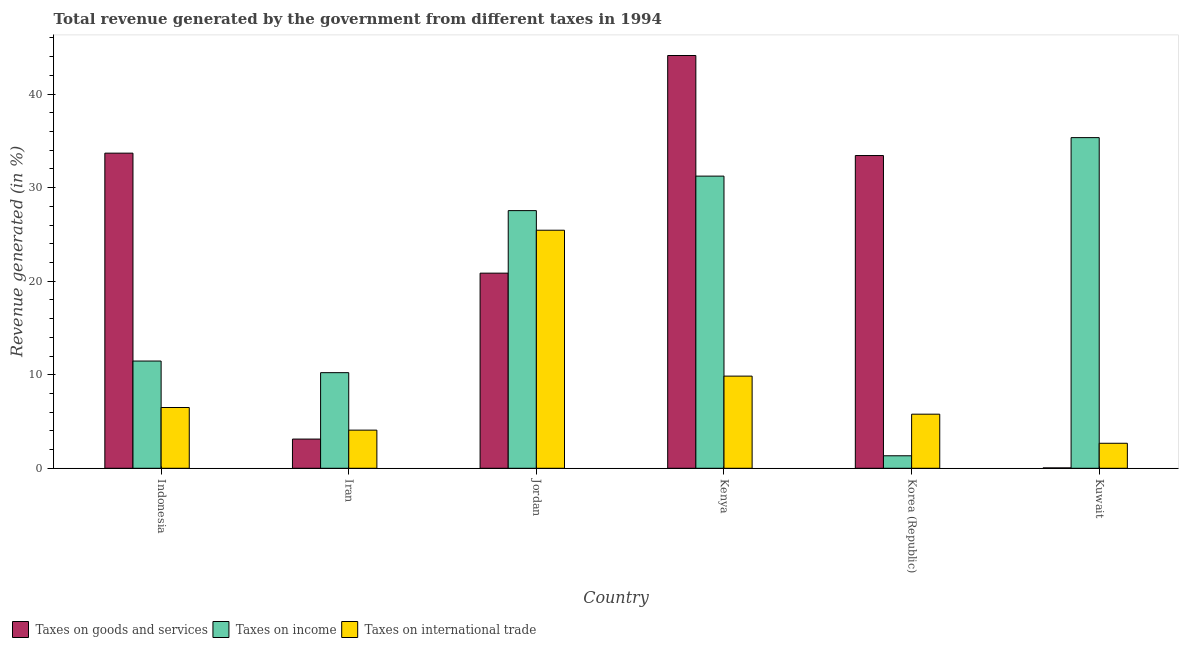How many groups of bars are there?
Your answer should be very brief. 6. Are the number of bars per tick equal to the number of legend labels?
Keep it short and to the point. Yes. How many bars are there on the 6th tick from the left?
Keep it short and to the point. 3. What is the label of the 3rd group of bars from the left?
Provide a succinct answer. Jordan. In how many cases, is the number of bars for a given country not equal to the number of legend labels?
Provide a succinct answer. 0. What is the percentage of revenue generated by taxes on income in Indonesia?
Ensure brevity in your answer.  11.46. Across all countries, what is the maximum percentage of revenue generated by taxes on goods and services?
Make the answer very short. 44.12. Across all countries, what is the minimum percentage of revenue generated by taxes on goods and services?
Provide a succinct answer. 0.04. In which country was the percentage of revenue generated by taxes on income maximum?
Provide a short and direct response. Kuwait. In which country was the percentage of revenue generated by taxes on goods and services minimum?
Offer a very short reply. Kuwait. What is the total percentage of revenue generated by tax on international trade in the graph?
Offer a terse response. 54.32. What is the difference between the percentage of revenue generated by taxes on goods and services in Indonesia and that in Korea (Republic)?
Make the answer very short. 0.26. What is the difference between the percentage of revenue generated by taxes on goods and services in Kenya and the percentage of revenue generated by tax on international trade in Indonesia?
Make the answer very short. 37.63. What is the average percentage of revenue generated by taxes on goods and services per country?
Ensure brevity in your answer.  22.54. What is the difference between the percentage of revenue generated by taxes on income and percentage of revenue generated by tax on international trade in Kenya?
Your answer should be very brief. 21.38. In how many countries, is the percentage of revenue generated by taxes on income greater than 28 %?
Offer a very short reply. 2. What is the ratio of the percentage of revenue generated by taxes on goods and services in Jordan to that in Korea (Republic)?
Ensure brevity in your answer.  0.62. Is the difference between the percentage of revenue generated by taxes on income in Iran and Kenya greater than the difference between the percentage of revenue generated by tax on international trade in Iran and Kenya?
Keep it short and to the point. No. What is the difference between the highest and the second highest percentage of revenue generated by taxes on income?
Your response must be concise. 4.11. What is the difference between the highest and the lowest percentage of revenue generated by tax on international trade?
Your response must be concise. 22.77. In how many countries, is the percentage of revenue generated by taxes on income greater than the average percentage of revenue generated by taxes on income taken over all countries?
Provide a short and direct response. 3. Is the sum of the percentage of revenue generated by tax on international trade in Jordan and Korea (Republic) greater than the maximum percentage of revenue generated by taxes on income across all countries?
Provide a short and direct response. No. What does the 1st bar from the left in Kuwait represents?
Provide a succinct answer. Taxes on goods and services. What does the 3rd bar from the right in Jordan represents?
Give a very brief answer. Taxes on goods and services. How many bars are there?
Provide a short and direct response. 18. Are all the bars in the graph horizontal?
Offer a terse response. No. How many countries are there in the graph?
Your answer should be compact. 6. Does the graph contain any zero values?
Your answer should be compact. No. Does the graph contain grids?
Provide a succinct answer. No. Where does the legend appear in the graph?
Ensure brevity in your answer.  Bottom left. How many legend labels are there?
Provide a short and direct response. 3. How are the legend labels stacked?
Give a very brief answer. Horizontal. What is the title of the graph?
Ensure brevity in your answer.  Total revenue generated by the government from different taxes in 1994. What is the label or title of the X-axis?
Your answer should be compact. Country. What is the label or title of the Y-axis?
Your response must be concise. Revenue generated (in %). What is the Revenue generated (in %) of Taxes on goods and services in Indonesia?
Your response must be concise. 33.68. What is the Revenue generated (in %) of Taxes on income in Indonesia?
Offer a very short reply. 11.46. What is the Revenue generated (in %) in Taxes on international trade in Indonesia?
Keep it short and to the point. 6.5. What is the Revenue generated (in %) of Taxes on goods and services in Iran?
Provide a succinct answer. 3.12. What is the Revenue generated (in %) in Taxes on income in Iran?
Offer a very short reply. 10.22. What is the Revenue generated (in %) of Taxes on international trade in Iran?
Give a very brief answer. 4.08. What is the Revenue generated (in %) of Taxes on goods and services in Jordan?
Your answer should be very brief. 20.86. What is the Revenue generated (in %) of Taxes on income in Jordan?
Your answer should be very brief. 27.54. What is the Revenue generated (in %) of Taxes on international trade in Jordan?
Your answer should be very brief. 25.45. What is the Revenue generated (in %) of Taxes on goods and services in Kenya?
Your answer should be compact. 44.12. What is the Revenue generated (in %) in Taxes on income in Kenya?
Your answer should be compact. 31.23. What is the Revenue generated (in %) in Taxes on international trade in Kenya?
Provide a succinct answer. 9.85. What is the Revenue generated (in %) in Taxes on goods and services in Korea (Republic)?
Provide a short and direct response. 33.43. What is the Revenue generated (in %) of Taxes on income in Korea (Republic)?
Your answer should be very brief. 1.34. What is the Revenue generated (in %) of Taxes on international trade in Korea (Republic)?
Provide a short and direct response. 5.78. What is the Revenue generated (in %) in Taxes on goods and services in Kuwait?
Your response must be concise. 0.04. What is the Revenue generated (in %) in Taxes on income in Kuwait?
Your answer should be compact. 35.34. What is the Revenue generated (in %) of Taxes on international trade in Kuwait?
Ensure brevity in your answer.  2.67. Across all countries, what is the maximum Revenue generated (in %) in Taxes on goods and services?
Your response must be concise. 44.12. Across all countries, what is the maximum Revenue generated (in %) of Taxes on income?
Make the answer very short. 35.34. Across all countries, what is the maximum Revenue generated (in %) of Taxes on international trade?
Ensure brevity in your answer.  25.45. Across all countries, what is the minimum Revenue generated (in %) in Taxes on goods and services?
Provide a succinct answer. 0.04. Across all countries, what is the minimum Revenue generated (in %) in Taxes on income?
Give a very brief answer. 1.34. Across all countries, what is the minimum Revenue generated (in %) in Taxes on international trade?
Offer a terse response. 2.67. What is the total Revenue generated (in %) in Taxes on goods and services in the graph?
Give a very brief answer. 135.25. What is the total Revenue generated (in %) of Taxes on income in the graph?
Offer a terse response. 117.13. What is the total Revenue generated (in %) in Taxes on international trade in the graph?
Give a very brief answer. 54.32. What is the difference between the Revenue generated (in %) in Taxes on goods and services in Indonesia and that in Iran?
Offer a very short reply. 30.56. What is the difference between the Revenue generated (in %) of Taxes on income in Indonesia and that in Iran?
Provide a short and direct response. 1.24. What is the difference between the Revenue generated (in %) of Taxes on international trade in Indonesia and that in Iran?
Your answer should be very brief. 2.42. What is the difference between the Revenue generated (in %) of Taxes on goods and services in Indonesia and that in Jordan?
Offer a very short reply. 12.83. What is the difference between the Revenue generated (in %) in Taxes on income in Indonesia and that in Jordan?
Your answer should be compact. -16.08. What is the difference between the Revenue generated (in %) of Taxes on international trade in Indonesia and that in Jordan?
Give a very brief answer. -18.95. What is the difference between the Revenue generated (in %) in Taxes on goods and services in Indonesia and that in Kenya?
Your answer should be very brief. -10.44. What is the difference between the Revenue generated (in %) in Taxes on income in Indonesia and that in Kenya?
Your response must be concise. -19.77. What is the difference between the Revenue generated (in %) of Taxes on international trade in Indonesia and that in Kenya?
Your answer should be compact. -3.36. What is the difference between the Revenue generated (in %) of Taxes on goods and services in Indonesia and that in Korea (Republic)?
Provide a short and direct response. 0.26. What is the difference between the Revenue generated (in %) of Taxes on income in Indonesia and that in Korea (Republic)?
Your answer should be very brief. 10.13. What is the difference between the Revenue generated (in %) in Taxes on international trade in Indonesia and that in Korea (Republic)?
Provide a short and direct response. 0.71. What is the difference between the Revenue generated (in %) of Taxes on goods and services in Indonesia and that in Kuwait?
Provide a short and direct response. 33.65. What is the difference between the Revenue generated (in %) of Taxes on income in Indonesia and that in Kuwait?
Make the answer very short. -23.88. What is the difference between the Revenue generated (in %) of Taxes on international trade in Indonesia and that in Kuwait?
Offer a terse response. 3.82. What is the difference between the Revenue generated (in %) of Taxes on goods and services in Iran and that in Jordan?
Offer a terse response. -17.74. What is the difference between the Revenue generated (in %) in Taxes on income in Iran and that in Jordan?
Give a very brief answer. -17.32. What is the difference between the Revenue generated (in %) of Taxes on international trade in Iran and that in Jordan?
Provide a short and direct response. -21.37. What is the difference between the Revenue generated (in %) in Taxes on goods and services in Iran and that in Kenya?
Provide a short and direct response. -41. What is the difference between the Revenue generated (in %) in Taxes on income in Iran and that in Kenya?
Make the answer very short. -21.01. What is the difference between the Revenue generated (in %) of Taxes on international trade in Iran and that in Kenya?
Your answer should be very brief. -5.77. What is the difference between the Revenue generated (in %) of Taxes on goods and services in Iran and that in Korea (Republic)?
Ensure brevity in your answer.  -30.31. What is the difference between the Revenue generated (in %) in Taxes on income in Iran and that in Korea (Republic)?
Give a very brief answer. 8.88. What is the difference between the Revenue generated (in %) of Taxes on international trade in Iran and that in Korea (Republic)?
Provide a short and direct response. -1.7. What is the difference between the Revenue generated (in %) of Taxes on goods and services in Iran and that in Kuwait?
Keep it short and to the point. 3.08. What is the difference between the Revenue generated (in %) in Taxes on income in Iran and that in Kuwait?
Offer a very short reply. -25.12. What is the difference between the Revenue generated (in %) of Taxes on international trade in Iran and that in Kuwait?
Provide a succinct answer. 1.41. What is the difference between the Revenue generated (in %) of Taxes on goods and services in Jordan and that in Kenya?
Your answer should be very brief. -23.26. What is the difference between the Revenue generated (in %) of Taxes on income in Jordan and that in Kenya?
Provide a short and direct response. -3.69. What is the difference between the Revenue generated (in %) of Taxes on international trade in Jordan and that in Kenya?
Offer a very short reply. 15.59. What is the difference between the Revenue generated (in %) of Taxes on goods and services in Jordan and that in Korea (Republic)?
Offer a terse response. -12.57. What is the difference between the Revenue generated (in %) of Taxes on income in Jordan and that in Korea (Republic)?
Offer a very short reply. 26.21. What is the difference between the Revenue generated (in %) of Taxes on international trade in Jordan and that in Korea (Republic)?
Your answer should be compact. 19.66. What is the difference between the Revenue generated (in %) in Taxes on goods and services in Jordan and that in Kuwait?
Your answer should be very brief. 20.82. What is the difference between the Revenue generated (in %) of Taxes on income in Jordan and that in Kuwait?
Give a very brief answer. -7.8. What is the difference between the Revenue generated (in %) of Taxes on international trade in Jordan and that in Kuwait?
Provide a succinct answer. 22.77. What is the difference between the Revenue generated (in %) of Taxes on goods and services in Kenya and that in Korea (Republic)?
Offer a terse response. 10.69. What is the difference between the Revenue generated (in %) in Taxes on income in Kenya and that in Korea (Republic)?
Provide a succinct answer. 29.89. What is the difference between the Revenue generated (in %) of Taxes on international trade in Kenya and that in Korea (Republic)?
Give a very brief answer. 4.07. What is the difference between the Revenue generated (in %) of Taxes on goods and services in Kenya and that in Kuwait?
Your answer should be compact. 44.08. What is the difference between the Revenue generated (in %) of Taxes on income in Kenya and that in Kuwait?
Offer a terse response. -4.11. What is the difference between the Revenue generated (in %) in Taxes on international trade in Kenya and that in Kuwait?
Your answer should be very brief. 7.18. What is the difference between the Revenue generated (in %) in Taxes on goods and services in Korea (Republic) and that in Kuwait?
Your answer should be very brief. 33.39. What is the difference between the Revenue generated (in %) of Taxes on income in Korea (Republic) and that in Kuwait?
Offer a very short reply. -34.01. What is the difference between the Revenue generated (in %) of Taxes on international trade in Korea (Republic) and that in Kuwait?
Your answer should be compact. 3.11. What is the difference between the Revenue generated (in %) in Taxes on goods and services in Indonesia and the Revenue generated (in %) in Taxes on income in Iran?
Keep it short and to the point. 23.47. What is the difference between the Revenue generated (in %) of Taxes on goods and services in Indonesia and the Revenue generated (in %) of Taxes on international trade in Iran?
Give a very brief answer. 29.61. What is the difference between the Revenue generated (in %) in Taxes on income in Indonesia and the Revenue generated (in %) in Taxes on international trade in Iran?
Your answer should be very brief. 7.39. What is the difference between the Revenue generated (in %) of Taxes on goods and services in Indonesia and the Revenue generated (in %) of Taxes on income in Jordan?
Offer a very short reply. 6.14. What is the difference between the Revenue generated (in %) of Taxes on goods and services in Indonesia and the Revenue generated (in %) of Taxes on international trade in Jordan?
Give a very brief answer. 8.24. What is the difference between the Revenue generated (in %) in Taxes on income in Indonesia and the Revenue generated (in %) in Taxes on international trade in Jordan?
Keep it short and to the point. -13.98. What is the difference between the Revenue generated (in %) in Taxes on goods and services in Indonesia and the Revenue generated (in %) in Taxes on income in Kenya?
Keep it short and to the point. 2.45. What is the difference between the Revenue generated (in %) in Taxes on goods and services in Indonesia and the Revenue generated (in %) in Taxes on international trade in Kenya?
Your answer should be very brief. 23.83. What is the difference between the Revenue generated (in %) in Taxes on income in Indonesia and the Revenue generated (in %) in Taxes on international trade in Kenya?
Your answer should be very brief. 1.61. What is the difference between the Revenue generated (in %) of Taxes on goods and services in Indonesia and the Revenue generated (in %) of Taxes on income in Korea (Republic)?
Keep it short and to the point. 32.35. What is the difference between the Revenue generated (in %) of Taxes on goods and services in Indonesia and the Revenue generated (in %) of Taxes on international trade in Korea (Republic)?
Make the answer very short. 27.9. What is the difference between the Revenue generated (in %) of Taxes on income in Indonesia and the Revenue generated (in %) of Taxes on international trade in Korea (Republic)?
Make the answer very short. 5.68. What is the difference between the Revenue generated (in %) in Taxes on goods and services in Indonesia and the Revenue generated (in %) in Taxes on income in Kuwait?
Your answer should be compact. -1.66. What is the difference between the Revenue generated (in %) in Taxes on goods and services in Indonesia and the Revenue generated (in %) in Taxes on international trade in Kuwait?
Keep it short and to the point. 31.01. What is the difference between the Revenue generated (in %) of Taxes on income in Indonesia and the Revenue generated (in %) of Taxes on international trade in Kuwait?
Provide a succinct answer. 8.79. What is the difference between the Revenue generated (in %) of Taxes on goods and services in Iran and the Revenue generated (in %) of Taxes on income in Jordan?
Offer a terse response. -24.42. What is the difference between the Revenue generated (in %) in Taxes on goods and services in Iran and the Revenue generated (in %) in Taxes on international trade in Jordan?
Ensure brevity in your answer.  -22.32. What is the difference between the Revenue generated (in %) in Taxes on income in Iran and the Revenue generated (in %) in Taxes on international trade in Jordan?
Provide a succinct answer. -15.23. What is the difference between the Revenue generated (in %) in Taxes on goods and services in Iran and the Revenue generated (in %) in Taxes on income in Kenya?
Offer a terse response. -28.11. What is the difference between the Revenue generated (in %) in Taxes on goods and services in Iran and the Revenue generated (in %) in Taxes on international trade in Kenya?
Make the answer very short. -6.73. What is the difference between the Revenue generated (in %) of Taxes on income in Iran and the Revenue generated (in %) of Taxes on international trade in Kenya?
Your response must be concise. 0.37. What is the difference between the Revenue generated (in %) in Taxes on goods and services in Iran and the Revenue generated (in %) in Taxes on income in Korea (Republic)?
Your answer should be compact. 1.78. What is the difference between the Revenue generated (in %) in Taxes on goods and services in Iran and the Revenue generated (in %) in Taxes on international trade in Korea (Republic)?
Your answer should be compact. -2.66. What is the difference between the Revenue generated (in %) in Taxes on income in Iran and the Revenue generated (in %) in Taxes on international trade in Korea (Republic)?
Keep it short and to the point. 4.44. What is the difference between the Revenue generated (in %) in Taxes on goods and services in Iran and the Revenue generated (in %) in Taxes on income in Kuwait?
Make the answer very short. -32.22. What is the difference between the Revenue generated (in %) of Taxes on goods and services in Iran and the Revenue generated (in %) of Taxes on international trade in Kuwait?
Keep it short and to the point. 0.45. What is the difference between the Revenue generated (in %) in Taxes on income in Iran and the Revenue generated (in %) in Taxes on international trade in Kuwait?
Your answer should be very brief. 7.55. What is the difference between the Revenue generated (in %) in Taxes on goods and services in Jordan and the Revenue generated (in %) in Taxes on income in Kenya?
Give a very brief answer. -10.37. What is the difference between the Revenue generated (in %) of Taxes on goods and services in Jordan and the Revenue generated (in %) of Taxes on international trade in Kenya?
Ensure brevity in your answer.  11.01. What is the difference between the Revenue generated (in %) of Taxes on income in Jordan and the Revenue generated (in %) of Taxes on international trade in Kenya?
Offer a terse response. 17.69. What is the difference between the Revenue generated (in %) of Taxes on goods and services in Jordan and the Revenue generated (in %) of Taxes on income in Korea (Republic)?
Your response must be concise. 19.52. What is the difference between the Revenue generated (in %) of Taxes on goods and services in Jordan and the Revenue generated (in %) of Taxes on international trade in Korea (Republic)?
Offer a very short reply. 15.08. What is the difference between the Revenue generated (in %) of Taxes on income in Jordan and the Revenue generated (in %) of Taxes on international trade in Korea (Republic)?
Give a very brief answer. 21.76. What is the difference between the Revenue generated (in %) in Taxes on goods and services in Jordan and the Revenue generated (in %) in Taxes on income in Kuwait?
Offer a terse response. -14.49. What is the difference between the Revenue generated (in %) in Taxes on goods and services in Jordan and the Revenue generated (in %) in Taxes on international trade in Kuwait?
Your response must be concise. 18.19. What is the difference between the Revenue generated (in %) in Taxes on income in Jordan and the Revenue generated (in %) in Taxes on international trade in Kuwait?
Keep it short and to the point. 24.87. What is the difference between the Revenue generated (in %) in Taxes on goods and services in Kenya and the Revenue generated (in %) in Taxes on income in Korea (Republic)?
Offer a terse response. 42.78. What is the difference between the Revenue generated (in %) of Taxes on goods and services in Kenya and the Revenue generated (in %) of Taxes on international trade in Korea (Republic)?
Provide a succinct answer. 38.34. What is the difference between the Revenue generated (in %) in Taxes on income in Kenya and the Revenue generated (in %) in Taxes on international trade in Korea (Republic)?
Offer a very short reply. 25.45. What is the difference between the Revenue generated (in %) in Taxes on goods and services in Kenya and the Revenue generated (in %) in Taxes on income in Kuwait?
Keep it short and to the point. 8.78. What is the difference between the Revenue generated (in %) in Taxes on goods and services in Kenya and the Revenue generated (in %) in Taxes on international trade in Kuwait?
Ensure brevity in your answer.  41.45. What is the difference between the Revenue generated (in %) in Taxes on income in Kenya and the Revenue generated (in %) in Taxes on international trade in Kuwait?
Your answer should be compact. 28.56. What is the difference between the Revenue generated (in %) of Taxes on goods and services in Korea (Republic) and the Revenue generated (in %) of Taxes on income in Kuwait?
Provide a succinct answer. -1.92. What is the difference between the Revenue generated (in %) in Taxes on goods and services in Korea (Republic) and the Revenue generated (in %) in Taxes on international trade in Kuwait?
Offer a very short reply. 30.76. What is the difference between the Revenue generated (in %) of Taxes on income in Korea (Republic) and the Revenue generated (in %) of Taxes on international trade in Kuwait?
Offer a very short reply. -1.34. What is the average Revenue generated (in %) of Taxes on goods and services per country?
Keep it short and to the point. 22.54. What is the average Revenue generated (in %) in Taxes on income per country?
Ensure brevity in your answer.  19.52. What is the average Revenue generated (in %) of Taxes on international trade per country?
Your answer should be compact. 9.05. What is the difference between the Revenue generated (in %) in Taxes on goods and services and Revenue generated (in %) in Taxes on income in Indonesia?
Your answer should be compact. 22.22. What is the difference between the Revenue generated (in %) of Taxes on goods and services and Revenue generated (in %) of Taxes on international trade in Indonesia?
Ensure brevity in your answer.  27.19. What is the difference between the Revenue generated (in %) of Taxes on income and Revenue generated (in %) of Taxes on international trade in Indonesia?
Your answer should be compact. 4.97. What is the difference between the Revenue generated (in %) of Taxes on goods and services and Revenue generated (in %) of Taxes on income in Iran?
Provide a succinct answer. -7.1. What is the difference between the Revenue generated (in %) in Taxes on goods and services and Revenue generated (in %) in Taxes on international trade in Iran?
Your answer should be compact. -0.96. What is the difference between the Revenue generated (in %) of Taxes on income and Revenue generated (in %) of Taxes on international trade in Iran?
Offer a terse response. 6.14. What is the difference between the Revenue generated (in %) of Taxes on goods and services and Revenue generated (in %) of Taxes on income in Jordan?
Offer a very short reply. -6.68. What is the difference between the Revenue generated (in %) of Taxes on goods and services and Revenue generated (in %) of Taxes on international trade in Jordan?
Your response must be concise. -4.59. What is the difference between the Revenue generated (in %) of Taxes on income and Revenue generated (in %) of Taxes on international trade in Jordan?
Your answer should be very brief. 2.1. What is the difference between the Revenue generated (in %) in Taxes on goods and services and Revenue generated (in %) in Taxes on income in Kenya?
Your answer should be compact. 12.89. What is the difference between the Revenue generated (in %) in Taxes on goods and services and Revenue generated (in %) in Taxes on international trade in Kenya?
Give a very brief answer. 34.27. What is the difference between the Revenue generated (in %) of Taxes on income and Revenue generated (in %) of Taxes on international trade in Kenya?
Your response must be concise. 21.38. What is the difference between the Revenue generated (in %) of Taxes on goods and services and Revenue generated (in %) of Taxes on income in Korea (Republic)?
Keep it short and to the point. 32.09. What is the difference between the Revenue generated (in %) of Taxes on goods and services and Revenue generated (in %) of Taxes on international trade in Korea (Republic)?
Make the answer very short. 27.65. What is the difference between the Revenue generated (in %) of Taxes on income and Revenue generated (in %) of Taxes on international trade in Korea (Republic)?
Provide a succinct answer. -4.45. What is the difference between the Revenue generated (in %) of Taxes on goods and services and Revenue generated (in %) of Taxes on income in Kuwait?
Keep it short and to the point. -35.3. What is the difference between the Revenue generated (in %) in Taxes on goods and services and Revenue generated (in %) in Taxes on international trade in Kuwait?
Keep it short and to the point. -2.63. What is the difference between the Revenue generated (in %) in Taxes on income and Revenue generated (in %) in Taxes on international trade in Kuwait?
Your response must be concise. 32.67. What is the ratio of the Revenue generated (in %) in Taxes on goods and services in Indonesia to that in Iran?
Your response must be concise. 10.79. What is the ratio of the Revenue generated (in %) of Taxes on income in Indonesia to that in Iran?
Provide a short and direct response. 1.12. What is the ratio of the Revenue generated (in %) of Taxes on international trade in Indonesia to that in Iran?
Your answer should be very brief. 1.59. What is the ratio of the Revenue generated (in %) in Taxes on goods and services in Indonesia to that in Jordan?
Keep it short and to the point. 1.61. What is the ratio of the Revenue generated (in %) of Taxes on income in Indonesia to that in Jordan?
Give a very brief answer. 0.42. What is the ratio of the Revenue generated (in %) in Taxes on international trade in Indonesia to that in Jordan?
Give a very brief answer. 0.26. What is the ratio of the Revenue generated (in %) in Taxes on goods and services in Indonesia to that in Kenya?
Offer a very short reply. 0.76. What is the ratio of the Revenue generated (in %) of Taxes on income in Indonesia to that in Kenya?
Offer a terse response. 0.37. What is the ratio of the Revenue generated (in %) of Taxes on international trade in Indonesia to that in Kenya?
Keep it short and to the point. 0.66. What is the ratio of the Revenue generated (in %) of Taxes on goods and services in Indonesia to that in Korea (Republic)?
Offer a terse response. 1.01. What is the ratio of the Revenue generated (in %) of Taxes on income in Indonesia to that in Korea (Republic)?
Keep it short and to the point. 8.58. What is the ratio of the Revenue generated (in %) of Taxes on international trade in Indonesia to that in Korea (Republic)?
Offer a terse response. 1.12. What is the ratio of the Revenue generated (in %) of Taxes on goods and services in Indonesia to that in Kuwait?
Make the answer very short. 857.27. What is the ratio of the Revenue generated (in %) in Taxes on income in Indonesia to that in Kuwait?
Your answer should be very brief. 0.32. What is the ratio of the Revenue generated (in %) in Taxes on international trade in Indonesia to that in Kuwait?
Ensure brevity in your answer.  2.43. What is the ratio of the Revenue generated (in %) in Taxes on goods and services in Iran to that in Jordan?
Provide a succinct answer. 0.15. What is the ratio of the Revenue generated (in %) of Taxes on income in Iran to that in Jordan?
Give a very brief answer. 0.37. What is the ratio of the Revenue generated (in %) in Taxes on international trade in Iran to that in Jordan?
Your response must be concise. 0.16. What is the ratio of the Revenue generated (in %) in Taxes on goods and services in Iran to that in Kenya?
Give a very brief answer. 0.07. What is the ratio of the Revenue generated (in %) of Taxes on income in Iran to that in Kenya?
Give a very brief answer. 0.33. What is the ratio of the Revenue generated (in %) in Taxes on international trade in Iran to that in Kenya?
Provide a succinct answer. 0.41. What is the ratio of the Revenue generated (in %) in Taxes on goods and services in Iran to that in Korea (Republic)?
Give a very brief answer. 0.09. What is the ratio of the Revenue generated (in %) of Taxes on income in Iran to that in Korea (Republic)?
Provide a short and direct response. 7.65. What is the ratio of the Revenue generated (in %) in Taxes on international trade in Iran to that in Korea (Republic)?
Offer a terse response. 0.71. What is the ratio of the Revenue generated (in %) of Taxes on goods and services in Iran to that in Kuwait?
Offer a very short reply. 79.43. What is the ratio of the Revenue generated (in %) of Taxes on income in Iran to that in Kuwait?
Your answer should be very brief. 0.29. What is the ratio of the Revenue generated (in %) in Taxes on international trade in Iran to that in Kuwait?
Your answer should be very brief. 1.53. What is the ratio of the Revenue generated (in %) of Taxes on goods and services in Jordan to that in Kenya?
Your answer should be compact. 0.47. What is the ratio of the Revenue generated (in %) in Taxes on income in Jordan to that in Kenya?
Make the answer very short. 0.88. What is the ratio of the Revenue generated (in %) of Taxes on international trade in Jordan to that in Kenya?
Make the answer very short. 2.58. What is the ratio of the Revenue generated (in %) in Taxes on goods and services in Jordan to that in Korea (Republic)?
Your answer should be very brief. 0.62. What is the ratio of the Revenue generated (in %) of Taxes on income in Jordan to that in Korea (Republic)?
Your answer should be very brief. 20.62. What is the ratio of the Revenue generated (in %) in Taxes on international trade in Jordan to that in Korea (Republic)?
Offer a very short reply. 4.4. What is the ratio of the Revenue generated (in %) in Taxes on goods and services in Jordan to that in Kuwait?
Give a very brief answer. 530.82. What is the ratio of the Revenue generated (in %) in Taxes on income in Jordan to that in Kuwait?
Your answer should be compact. 0.78. What is the ratio of the Revenue generated (in %) of Taxes on international trade in Jordan to that in Kuwait?
Your answer should be compact. 9.52. What is the ratio of the Revenue generated (in %) in Taxes on goods and services in Kenya to that in Korea (Republic)?
Give a very brief answer. 1.32. What is the ratio of the Revenue generated (in %) in Taxes on income in Kenya to that in Korea (Republic)?
Your answer should be very brief. 23.38. What is the ratio of the Revenue generated (in %) in Taxes on international trade in Kenya to that in Korea (Republic)?
Provide a succinct answer. 1.7. What is the ratio of the Revenue generated (in %) in Taxes on goods and services in Kenya to that in Kuwait?
Give a very brief answer. 1122.87. What is the ratio of the Revenue generated (in %) in Taxes on income in Kenya to that in Kuwait?
Provide a succinct answer. 0.88. What is the ratio of the Revenue generated (in %) in Taxes on international trade in Kenya to that in Kuwait?
Provide a succinct answer. 3.69. What is the ratio of the Revenue generated (in %) in Taxes on goods and services in Korea (Republic) to that in Kuwait?
Ensure brevity in your answer.  850.75. What is the ratio of the Revenue generated (in %) in Taxes on income in Korea (Republic) to that in Kuwait?
Give a very brief answer. 0.04. What is the ratio of the Revenue generated (in %) in Taxes on international trade in Korea (Republic) to that in Kuwait?
Make the answer very short. 2.16. What is the difference between the highest and the second highest Revenue generated (in %) in Taxes on goods and services?
Make the answer very short. 10.44. What is the difference between the highest and the second highest Revenue generated (in %) in Taxes on income?
Provide a short and direct response. 4.11. What is the difference between the highest and the second highest Revenue generated (in %) of Taxes on international trade?
Your answer should be compact. 15.59. What is the difference between the highest and the lowest Revenue generated (in %) of Taxes on goods and services?
Keep it short and to the point. 44.08. What is the difference between the highest and the lowest Revenue generated (in %) in Taxes on income?
Your response must be concise. 34.01. What is the difference between the highest and the lowest Revenue generated (in %) in Taxes on international trade?
Your response must be concise. 22.77. 